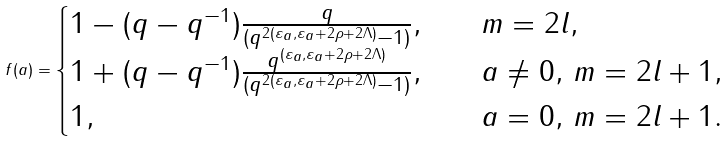Convert formula to latex. <formula><loc_0><loc_0><loc_500><loc_500>f ( a ) = \begin{cases} 1 - ( q - q ^ { - 1 } ) \frac { q } { ( q ^ { 2 ( \varepsilon _ { a } , \varepsilon _ { a } + 2 \rho + 2 \Lambda ) } - 1 ) } , & m = 2 l , \\ 1 + ( q - q ^ { - 1 } ) \frac { q ^ { ( \varepsilon _ { a } , \varepsilon _ { a } + 2 \rho + 2 \Lambda ) } } { ( q ^ { 2 ( \varepsilon _ { a } , \varepsilon _ { a } + 2 \rho + 2 \Lambda ) } - 1 ) } , \quad & a \neq 0 , \, m = 2 l + 1 , \\ 1 , & a = 0 , \, m = 2 l + 1 . \end{cases}</formula> 